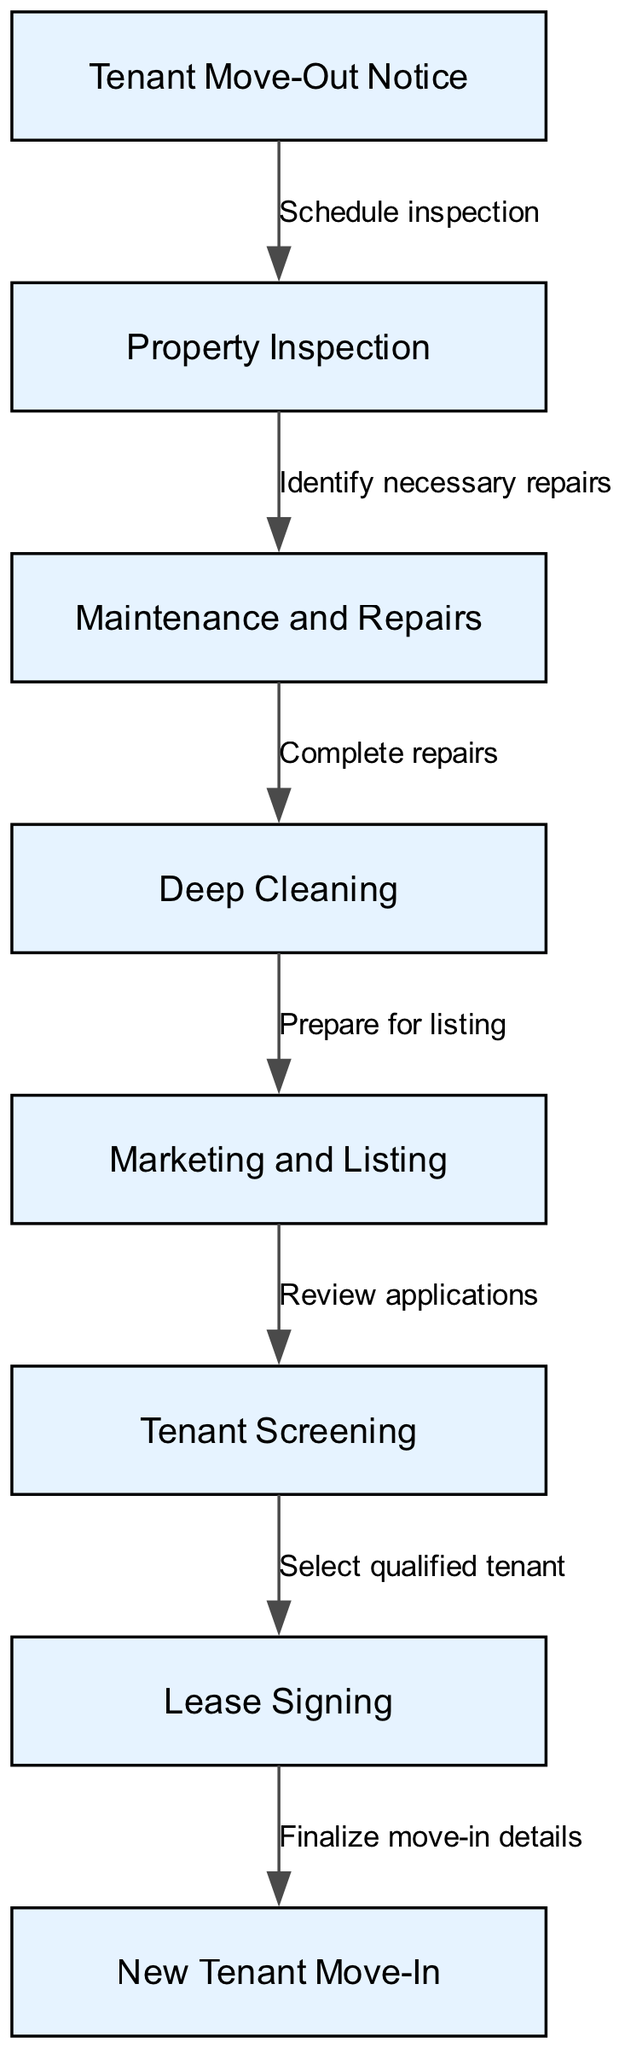What is the starting point of the tenant turnover process? The first node in the diagram is "Tenant Move-Out Notice," which indicates that this is the initial step in the turnover process.
Answer: Tenant Move-Out Notice How many nodes are present in the diagram? By counting the distinct labeled steps in the diagram, we find there are eight nodes that represent various stages of the tenant turnover process.
Answer: Eight What is the action taken after the property inspection? After the "Property Inspection," the next action is to "Identify necessary repairs," which flows directly from the inspection step.
Answer: Identify necessary repairs What label connects Maintenance and Repairs to Deep Cleaning? The edge connecting "Maintenance and Repairs" to "Deep Cleaning" is labeled "Complete repairs," indicating that repairs must be finalized before cleaning begins.
Answer: Complete repairs What is the final step before a new tenant can move in? The last step leading to tenant occupancy is "Finalize move-in details," which follows the process of lease signing and is essential for completing the turnover.
Answer: Finalize move-in details Which node follows Marketing and Listing? The node that follows "Marketing and Listing" is "Tenant Screening," representing the sequence of steps in finding a suitable tenant after the property has been listed.
Answer: Tenant Screening How many edges are there in the diagram? By counting the connections between nodes, we find there are seven edges that represent the flow of the process from one step to another.
Answer: Seven What two nodes are connected by the edge labeled as "Select qualified tenant"? The edge labeled "Select qualified tenant" connects "Tenant Screening" and "Lease Signing," which signifies the transition from choosing a tenant to finalizing lease terms.
Answer: Tenant Screening and Lease Signing 